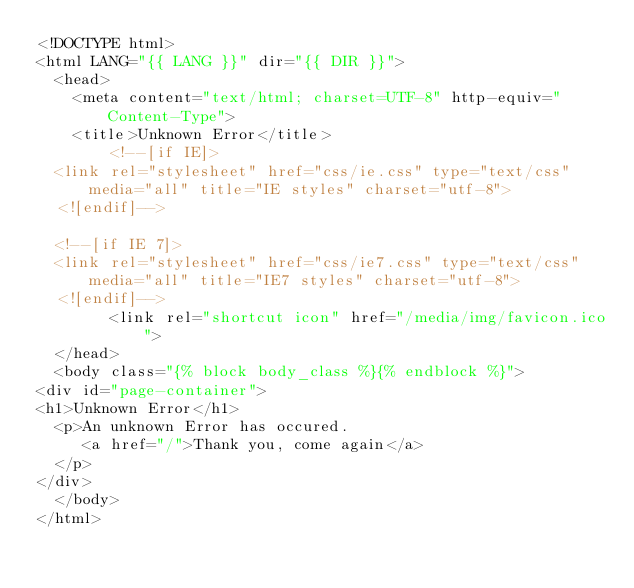Convert code to text. <code><loc_0><loc_0><loc_500><loc_500><_HTML_><!DOCTYPE html>
<html LANG="{{ LANG }}" dir="{{ DIR }}">
  <head>
    <meta content="text/html; charset=UTF-8" http-equiv="Content-Type">
    <title>Unknown Error</title>
        <!--[if IE]>
	<link rel="stylesheet" href="css/ie.css" type="text/css" media="all" title="IE styles" charset="utf-8">
	<![endif]-->
	
	<!--[if IE 7]>
	<link rel="stylesheet" href="css/ie7.css" type="text/css" media="all" title="IE7 styles" charset="utf-8">
	<![endif]-->
        <link rel="shortcut icon" href="/media/img/favicon.ico">
  </head>
  <body class="{% block body_class %}{% endblock %}">
<div id="page-container">
<h1>Unknown Error</h1>
  <p>An unknown Error has occured.
     <a href="/">Thank you, come again</a>
  </p>
</div>
  </body>
</html>

</code> 